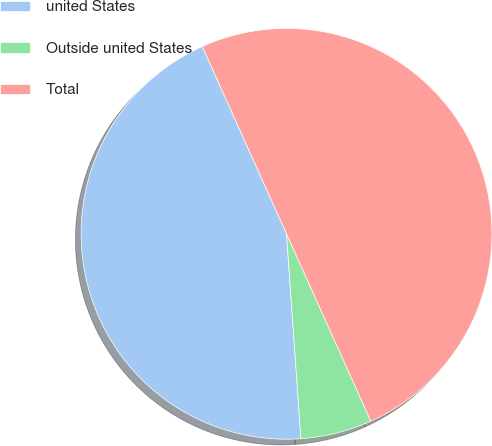Convert chart to OTSL. <chart><loc_0><loc_0><loc_500><loc_500><pie_chart><fcel>united States<fcel>Outside united States<fcel>Total<nl><fcel>44.39%<fcel>5.61%<fcel>50.0%<nl></chart> 